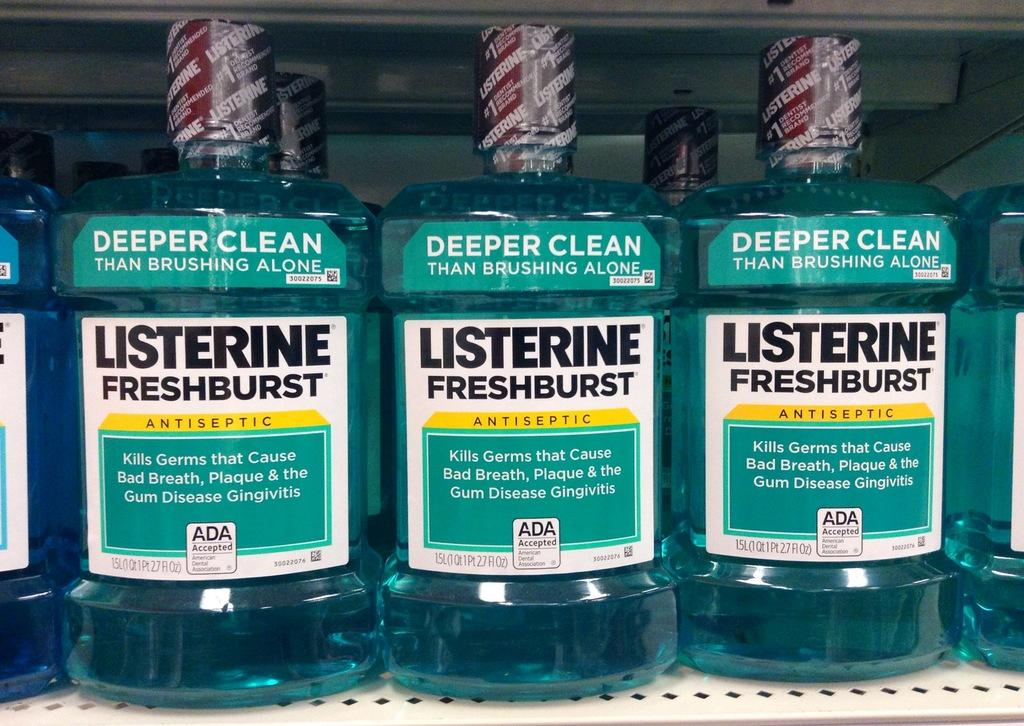<image>
Create a compact narrative representing the image presented. Three bottles of Listerine Freshburst sit on a shelf. 